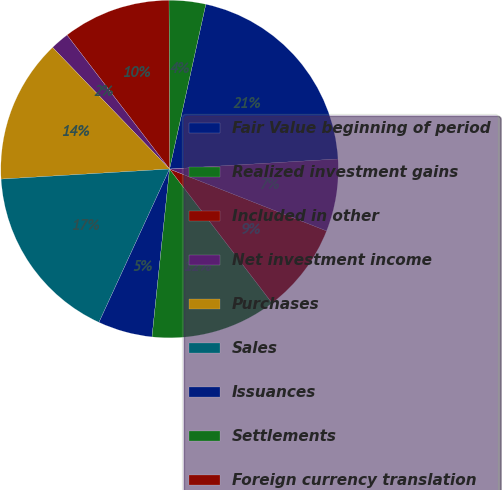Convert chart to OTSL. <chart><loc_0><loc_0><loc_500><loc_500><pie_chart><fcel>Fair Value beginning of period<fcel>Realized investment gains<fcel>Included in other<fcel>Net investment income<fcel>Purchases<fcel>Sales<fcel>Issuances<fcel>Settlements<fcel>Foreign currency translation<fcel>Other(1)<nl><fcel>20.6%<fcel>3.5%<fcel>10.34%<fcel>1.79%<fcel>13.76%<fcel>17.18%<fcel>5.21%<fcel>12.05%<fcel>8.63%<fcel>6.92%<nl></chart> 